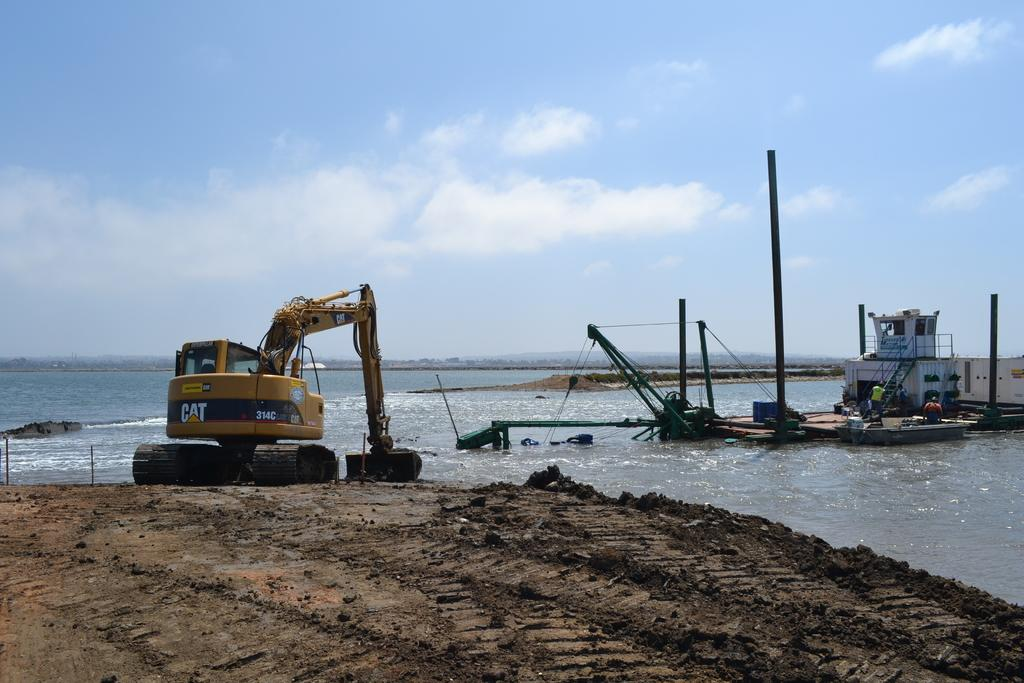What color is the crane in the image? The crane in the image is yellow. Where is the crane located? The crane is on the bank of a river. What other structures can be seen in the image? There is a dock in the image. What is visible in the background of the image? There is a river and the sky visible in the background. What can be observed in the sky? Clouds are present in the sky. How many songs can be heard playing in the background of the image? There is no sound or music present in the image, so it is not possible to determine how many songs can be heard. 